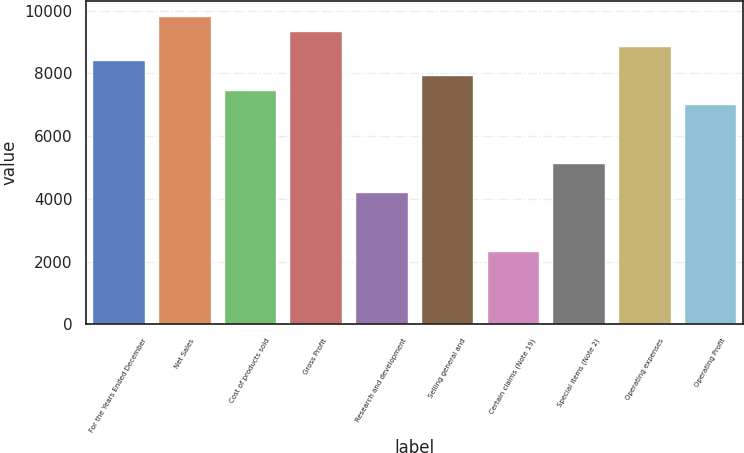Convert chart. <chart><loc_0><loc_0><loc_500><loc_500><bar_chart><fcel>For the Years Ended December<fcel>Net Sales<fcel>Cost of products sold<fcel>Gross Profit<fcel>Research and development<fcel>Selling general and<fcel>Certain claims (Note 19)<fcel>Special items (Note 2)<fcel>Operating expenses<fcel>Operating Profit<nl><fcel>8411.2<fcel>9812.92<fcel>7476.72<fcel>9345.68<fcel>4206.04<fcel>7943.96<fcel>2337.08<fcel>5140.52<fcel>8878.44<fcel>7009.48<nl></chart> 